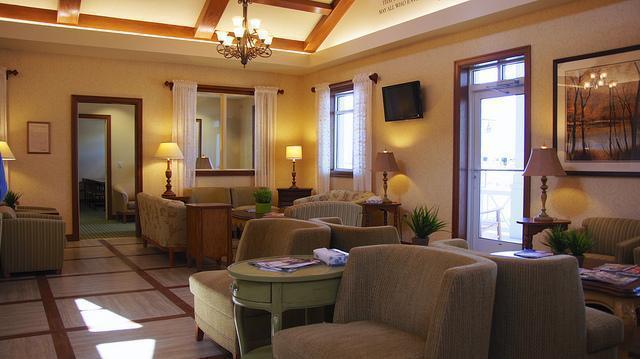What type room is this?
Pick the correct solution from the four options below to address the question.
Options: Bedroom, office, kitchen, lounge. Lounge. 